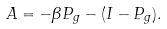<formula> <loc_0><loc_0><loc_500><loc_500>A = - \beta P _ { g } - ( I - P _ { g } ) .</formula> 